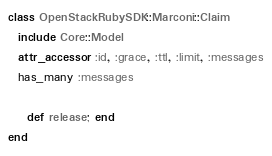Convert code to text. <code><loc_0><loc_0><loc_500><loc_500><_Ruby_>class OpenStackRubySDK::Marconi::Claim 
  include Core::Model
  attr_accessor :id, :grace, :ttl, :limit, :messages
  has_many :messages

	def release; end
end
</code> 